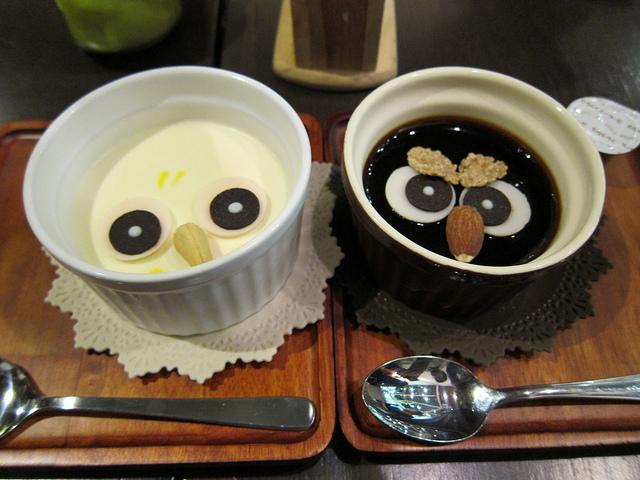How many cups of food are on the trays?
Short answer required. 2. Is the desert funny?
Short answer required. Yes. What animal do these look like?
Short answer required. Owls. What are the eyes made out of?
Short answer required. Chocolate. 